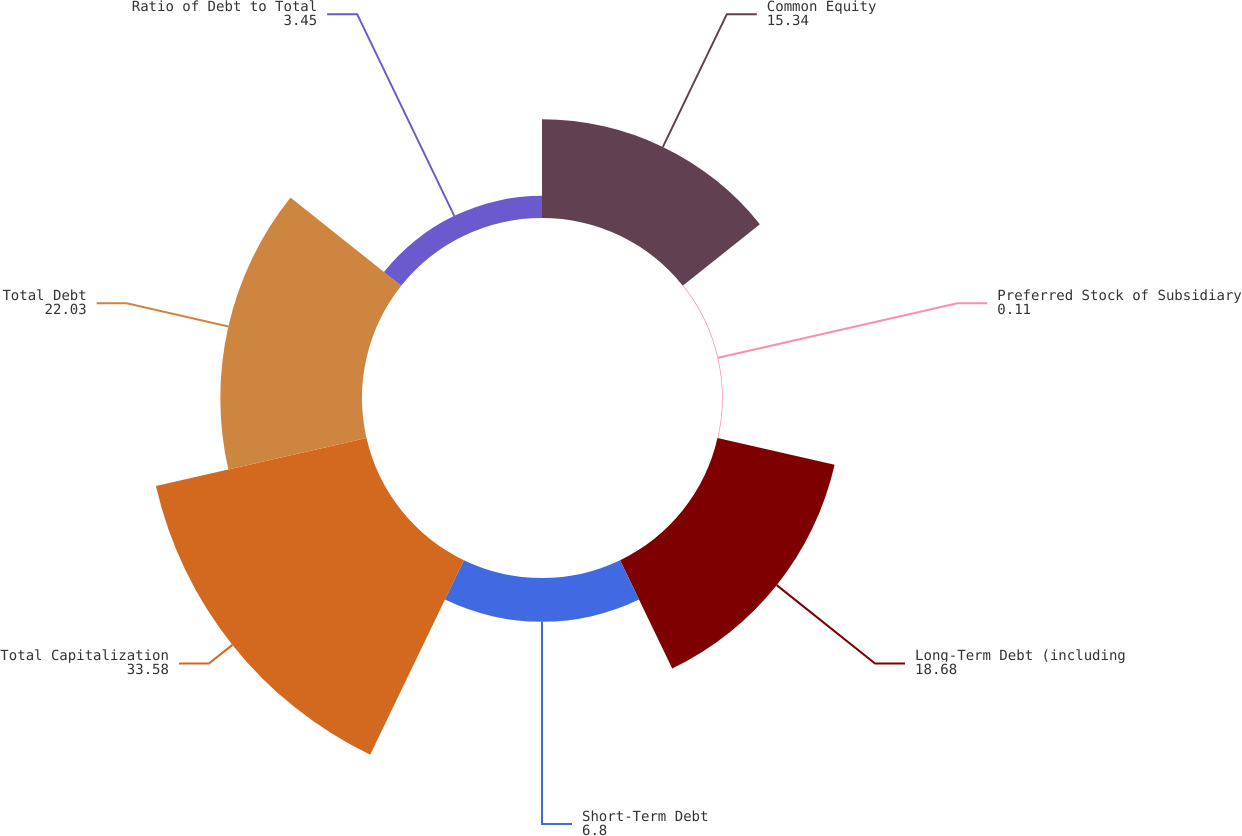Convert chart to OTSL. <chart><loc_0><loc_0><loc_500><loc_500><pie_chart><fcel>Common Equity<fcel>Preferred Stock of Subsidiary<fcel>Long-Term Debt (including<fcel>Short-Term Debt<fcel>Total Capitalization<fcel>Total Debt<fcel>Ratio of Debt to Total<nl><fcel>15.34%<fcel>0.11%<fcel>18.68%<fcel>6.8%<fcel>33.58%<fcel>22.03%<fcel>3.45%<nl></chart> 